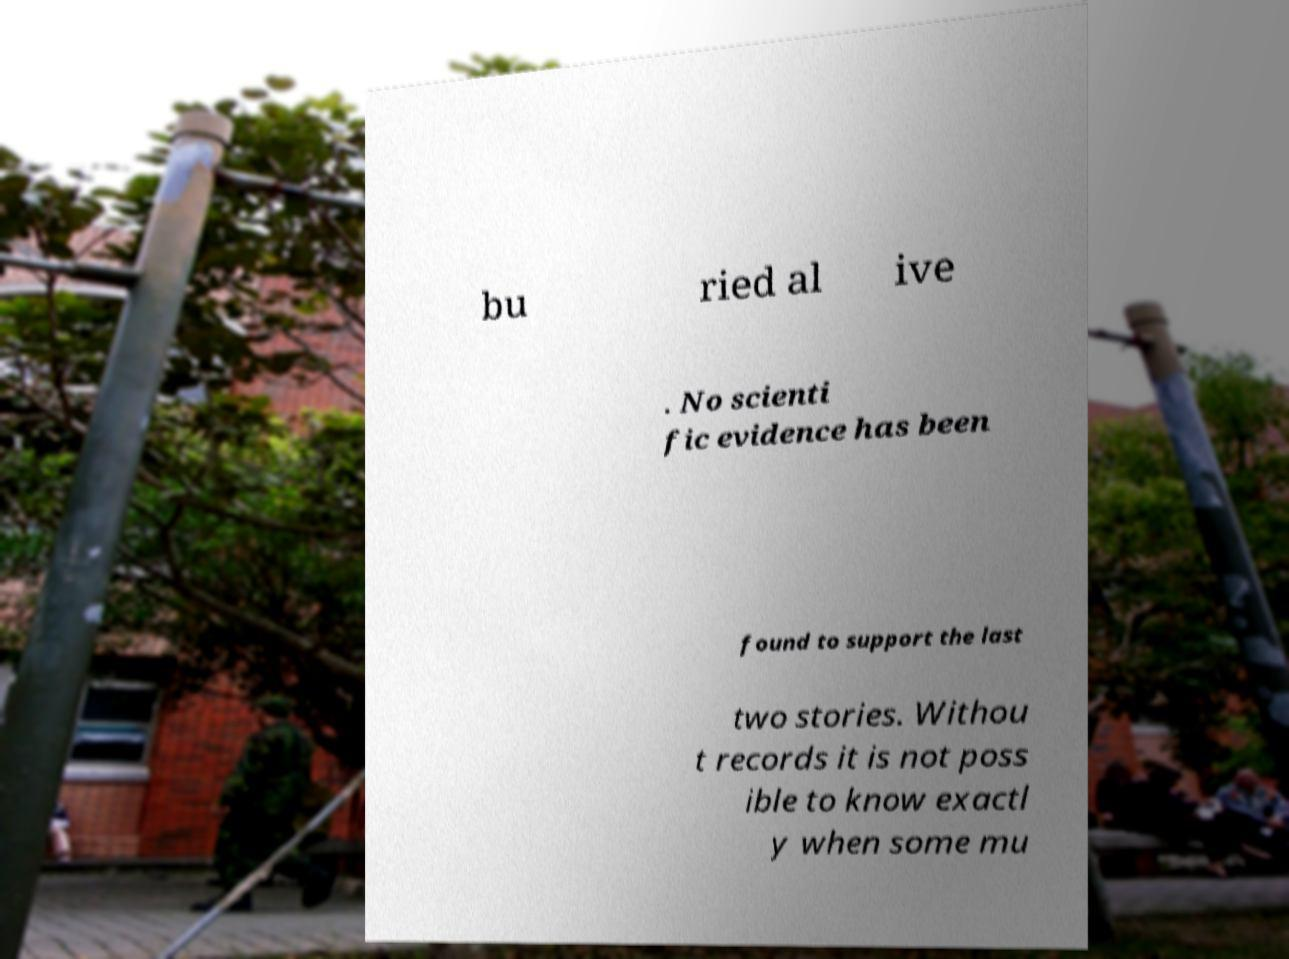Can you accurately transcribe the text from the provided image for me? bu ried al ive . No scienti fic evidence has been found to support the last two stories. Withou t records it is not poss ible to know exactl y when some mu 